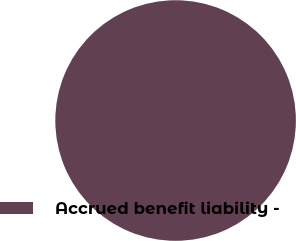Convert chart. <chart><loc_0><loc_0><loc_500><loc_500><pie_chart><fcel>Accrued benefit liability -<nl><fcel>100.0%<nl></chart> 